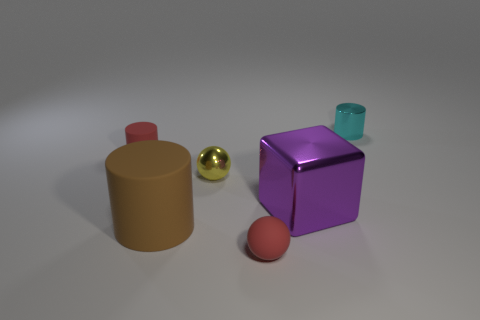Subtract all big cylinders. How many cylinders are left? 2 Add 4 large shiny things. How many objects exist? 10 Subtract all cyan cylinders. How many cylinders are left? 2 Subtract all balls. How many objects are left? 4 Subtract all green cylinders. Subtract all brown cubes. How many cylinders are left? 3 Add 4 red matte cubes. How many red matte cubes exist? 4 Subtract 0 gray balls. How many objects are left? 6 Subtract all large brown objects. Subtract all small red objects. How many objects are left? 3 Add 6 large purple blocks. How many large purple blocks are left? 7 